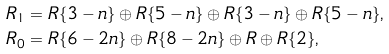<formula> <loc_0><loc_0><loc_500><loc_500>R _ { 1 } & = R \{ 3 - n \} \oplus R \{ 5 - n \} \oplus R \{ 3 - n \} \oplus R \{ 5 - n \} \text {,} \\ R _ { 0 } & = R \{ 6 - 2 n \} \oplus R \{ 8 - 2 n \} \oplus R \oplus R \{ 2 \} \text {,}</formula> 